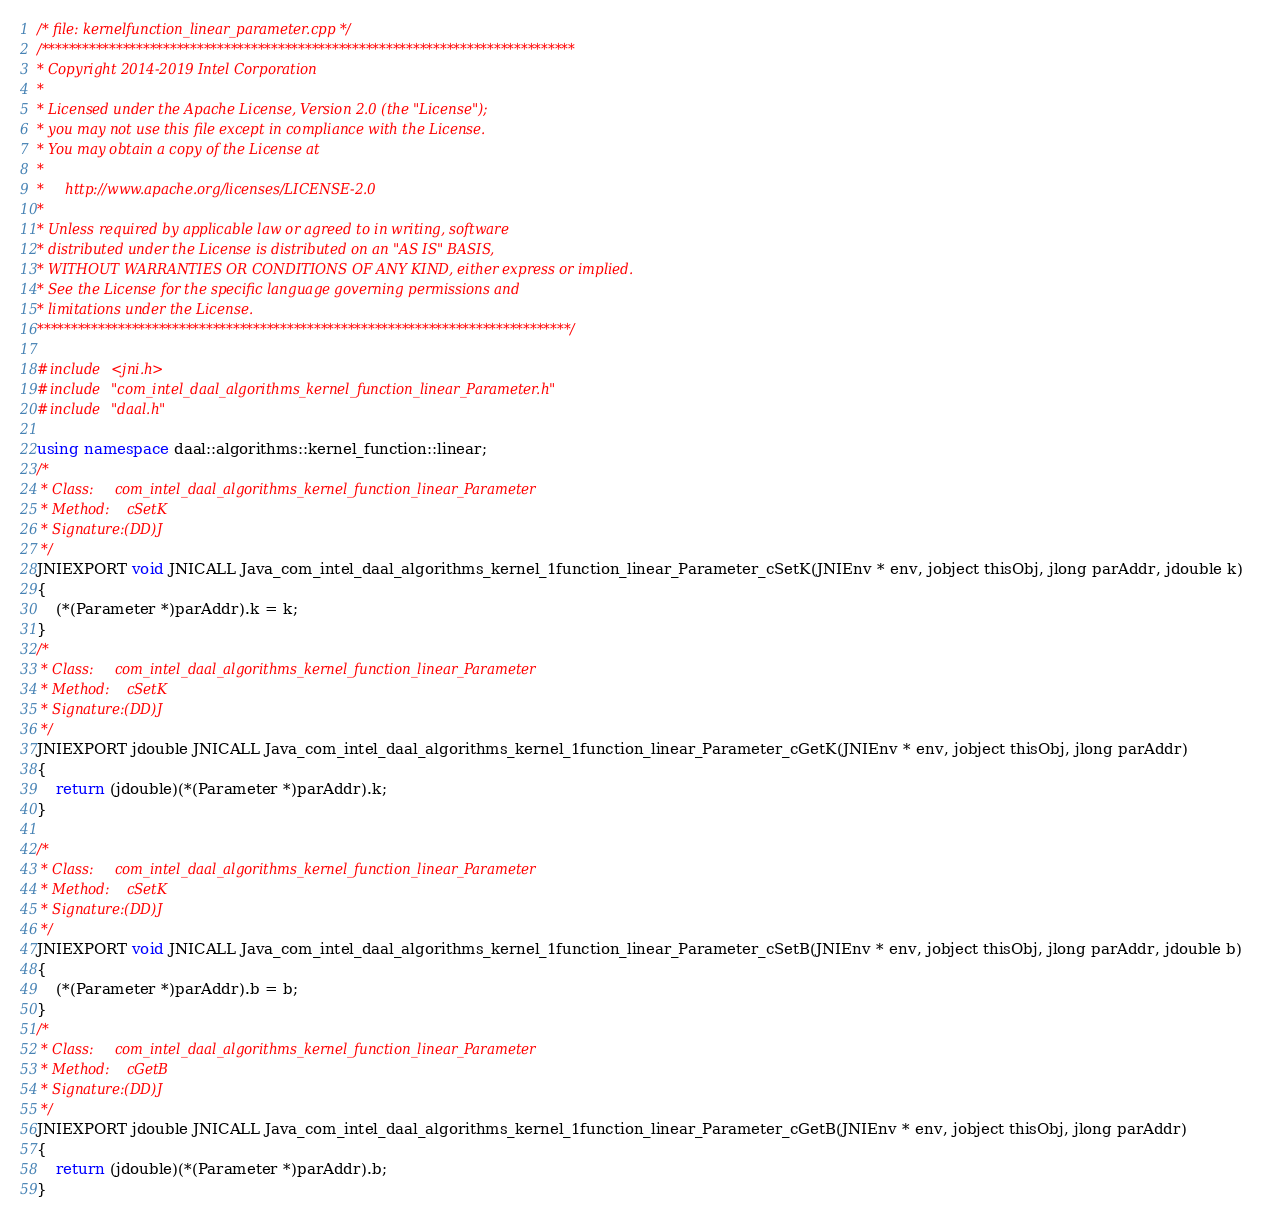Convert code to text. <code><loc_0><loc_0><loc_500><loc_500><_C++_>/* file: kernelfunction_linear_parameter.cpp */
/*******************************************************************************
* Copyright 2014-2019 Intel Corporation
*
* Licensed under the Apache License, Version 2.0 (the "License");
* you may not use this file except in compliance with the License.
* You may obtain a copy of the License at
*
*     http://www.apache.org/licenses/LICENSE-2.0
*
* Unless required by applicable law or agreed to in writing, software
* distributed under the License is distributed on an "AS IS" BASIS,
* WITHOUT WARRANTIES OR CONDITIONS OF ANY KIND, either express or implied.
* See the License for the specific language governing permissions and
* limitations under the License.
*******************************************************************************/

#include <jni.h>
#include "com_intel_daal_algorithms_kernel_function_linear_Parameter.h"
#include "daal.h"

using namespace daal::algorithms::kernel_function::linear;
/*
 * Class:     com_intel_daal_algorithms_kernel_function_linear_Parameter
 * Method:    cSetK
 * Signature:(DD)J
 */
JNIEXPORT void JNICALL Java_com_intel_daal_algorithms_kernel_1function_linear_Parameter_cSetK(JNIEnv * env, jobject thisObj, jlong parAddr, jdouble k)
{
    (*(Parameter *)parAddr).k = k;
}
/*
 * Class:     com_intel_daal_algorithms_kernel_function_linear_Parameter
 * Method:    cSetK
 * Signature:(DD)J
 */
JNIEXPORT jdouble JNICALL Java_com_intel_daal_algorithms_kernel_1function_linear_Parameter_cGetK(JNIEnv * env, jobject thisObj, jlong parAddr)
{
    return (jdouble)(*(Parameter *)parAddr).k;
}

/*
 * Class:     com_intel_daal_algorithms_kernel_function_linear_Parameter
 * Method:    cSetK
 * Signature:(DD)J
 */
JNIEXPORT void JNICALL Java_com_intel_daal_algorithms_kernel_1function_linear_Parameter_cSetB(JNIEnv * env, jobject thisObj, jlong parAddr, jdouble b)
{
    (*(Parameter *)parAddr).b = b;
}
/*
 * Class:     com_intel_daal_algorithms_kernel_function_linear_Parameter
 * Method:    cGetB
 * Signature:(DD)J
 */
JNIEXPORT jdouble JNICALL Java_com_intel_daal_algorithms_kernel_1function_linear_Parameter_cGetB(JNIEnv * env, jobject thisObj, jlong parAddr)
{
    return (jdouble)(*(Parameter *)parAddr).b;
}
</code> 